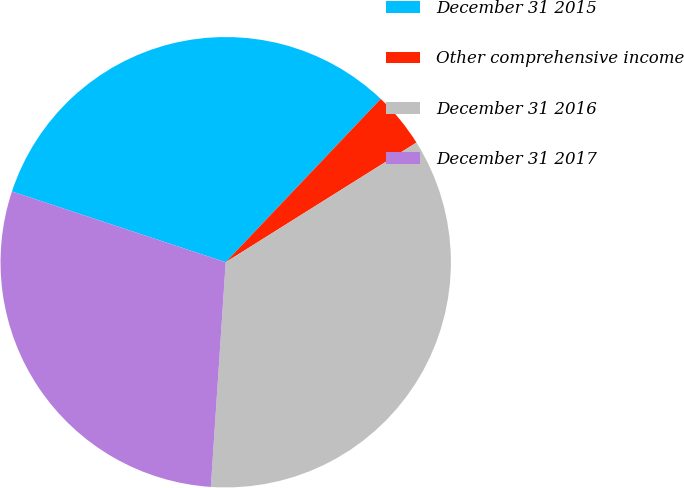Convert chart to OTSL. <chart><loc_0><loc_0><loc_500><loc_500><pie_chart><fcel>December 31 2015<fcel>Other comprehensive income<fcel>December 31 2016<fcel>December 31 2017<nl><fcel>32.0%<fcel>4.0%<fcel>34.97%<fcel>29.04%<nl></chart> 